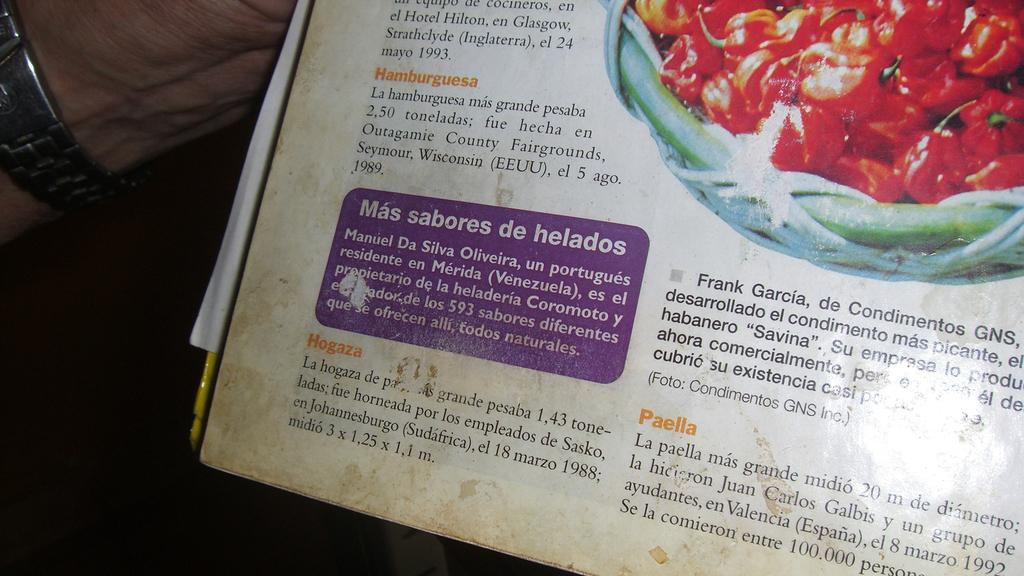<image>
Write a terse but informative summary of the picture. A spanish book with the heading Mas sabores de helados in a purple box. 